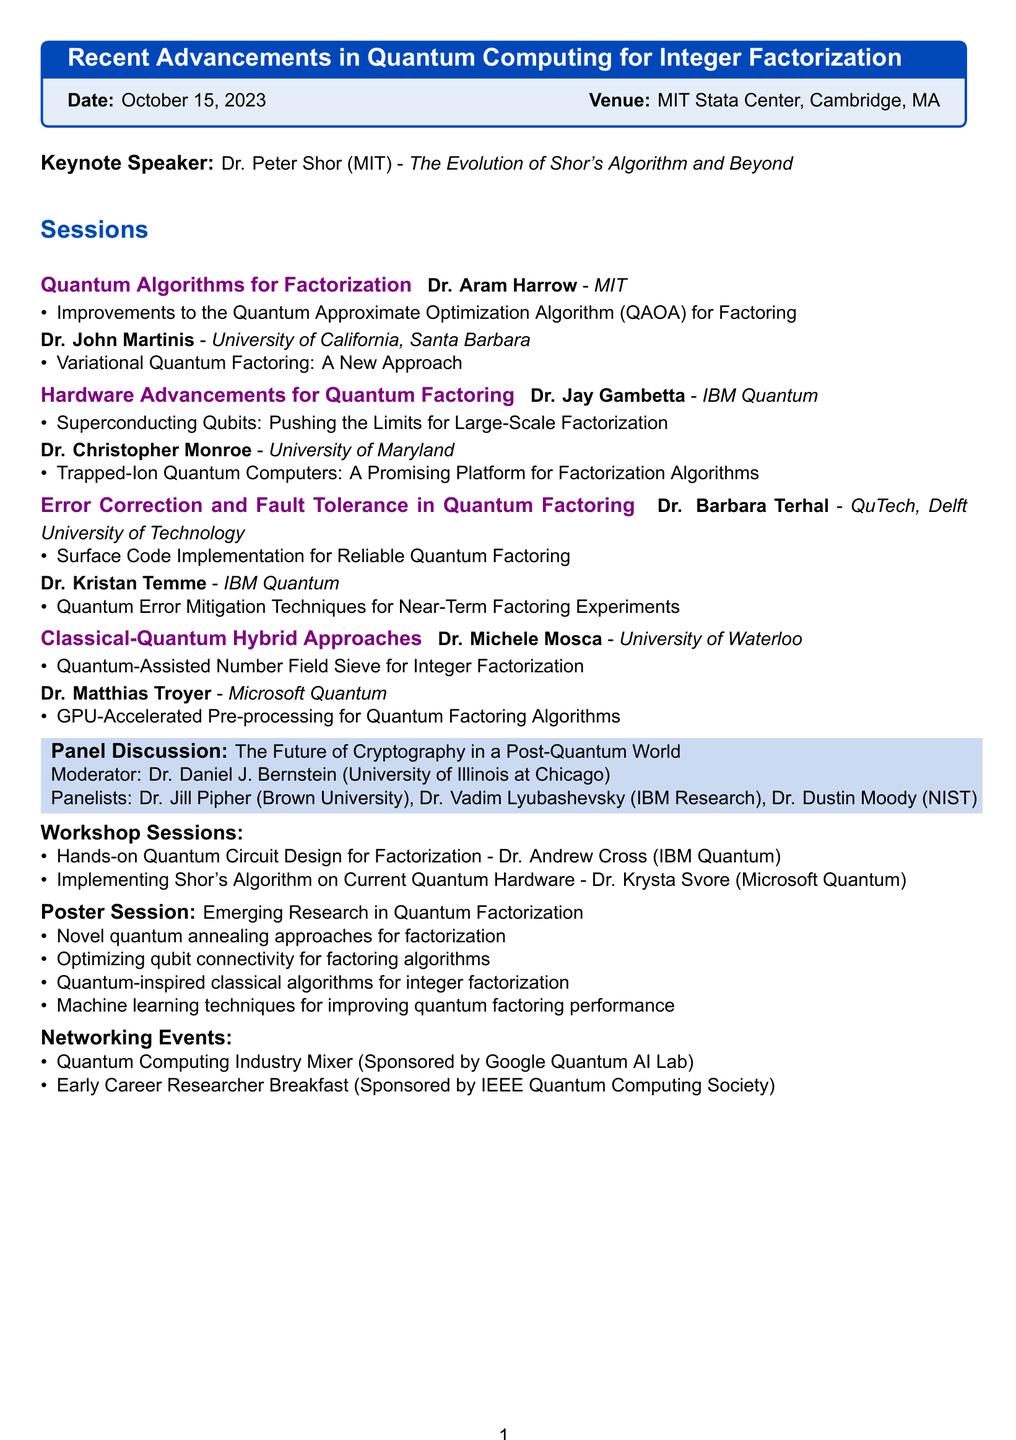What is the title of the seminar? The title of the seminar is stated at the beginning of the document.
Answer: Recent Advancements in Quantum Computing for Integer Factorization Who is the keynote speaker? The document lists the keynote speaker after the title of the seminar.
Answer: Dr. Peter Shor When is the seminar scheduled? The date of the seminar is noted in the introductory section of the document.
Answer: October 15, 2023 What university is Dr. John Martinis affiliated with? The affiliation of Dr. John Martinis is mentioned in the session details.
Answer: University of California, Santa Barbara What topic will be discussed in the panel discussion? The topic of the panel discussion is specified in the section labeled as such.
Answer: The Future of Cryptography in a Post-Quantum World How many workshop sessions are planned? The number of workshop sessions can be counted from the workshop sessions part of the document.
Answer: 2 Who is moderating the panel discussion? The name of the moderator for the panel discussion is listed in that section.
Answer: Dr. Daniel J. Bernstein What is one topic mentioned in the poster session? The document lists topics covered in the poster session, which can be referenced.
Answer: Novel quantum annealing approaches for factorization What is one of the networking events mentioned? The networking events are listed, allowing identification of specific events.
Answer: Quantum Computing Industry Mixer 